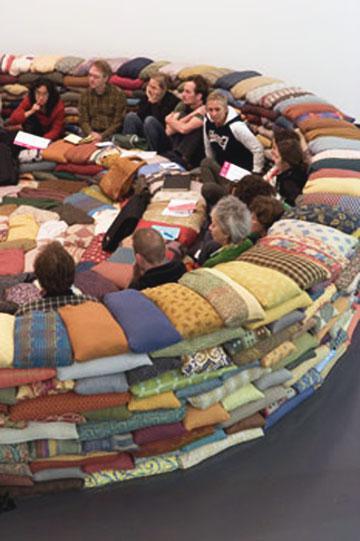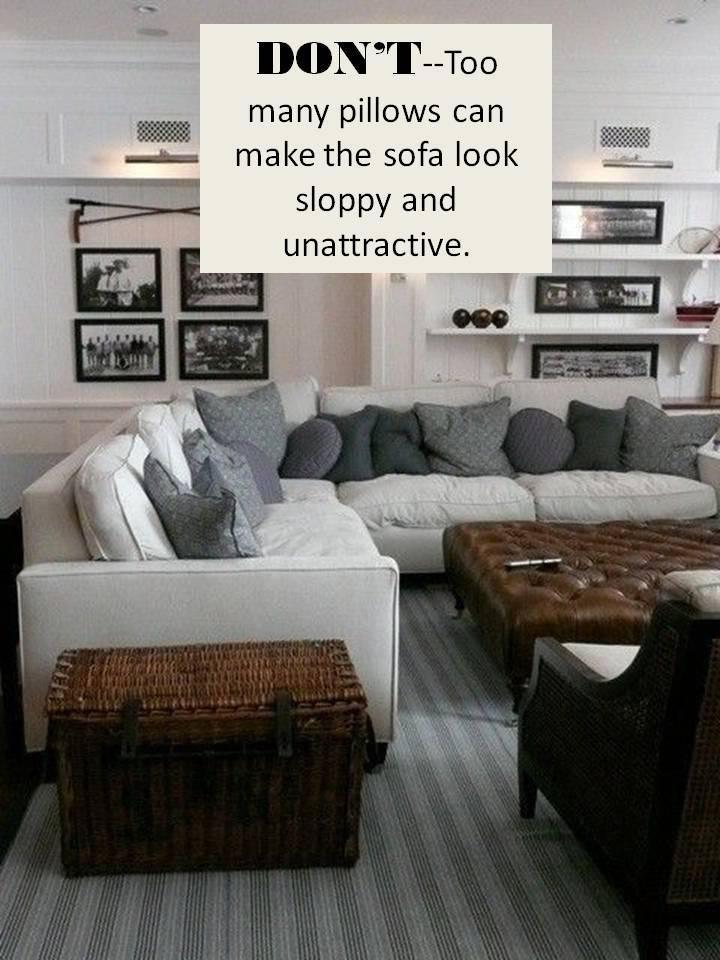The first image is the image on the left, the second image is the image on the right. For the images displayed, is the sentence "There is a couch with rolled arms and at least one of its pillows has a bold, geometric black and white design." factually correct? Answer yes or no. No. The first image is the image on the left, the second image is the image on the right. For the images displayed, is the sentence "There is a blue couch on the right image" factually correct? Answer yes or no. No. 